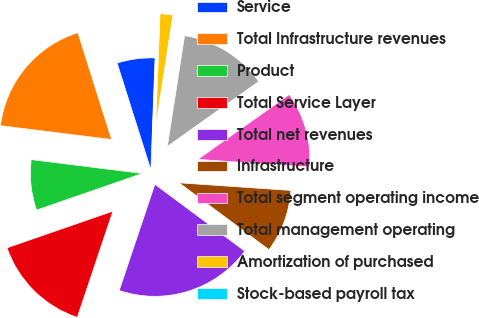<chart> <loc_0><loc_0><loc_500><loc_500><pie_chart><fcel>Service<fcel>Total Infrastructure revenues<fcel>Product<fcel>Total Service Layer<fcel>Total net revenues<fcel>Infrastructure<fcel>Total segment operating income<fcel>Total management operating<fcel>Amortization of purchased<fcel>Stock-based payroll tax<nl><fcel>5.46%<fcel>18.16%<fcel>7.28%<fcel>14.54%<fcel>19.98%<fcel>9.09%<fcel>10.91%<fcel>12.72%<fcel>1.84%<fcel>0.02%<nl></chart> 